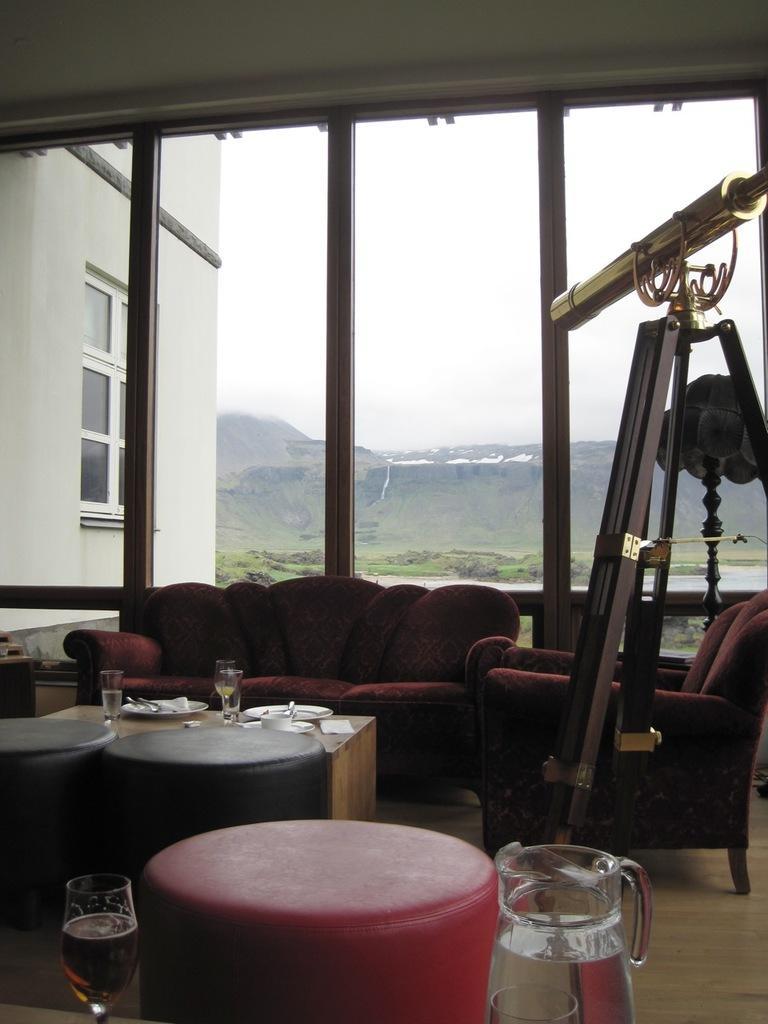Could you give a brief overview of what you see in this image? In this picture we can see the inside view of the room. In the front we can see small round tables. Behind there is a red sofa. In the background we can see a glass wall and hilly with trees. 